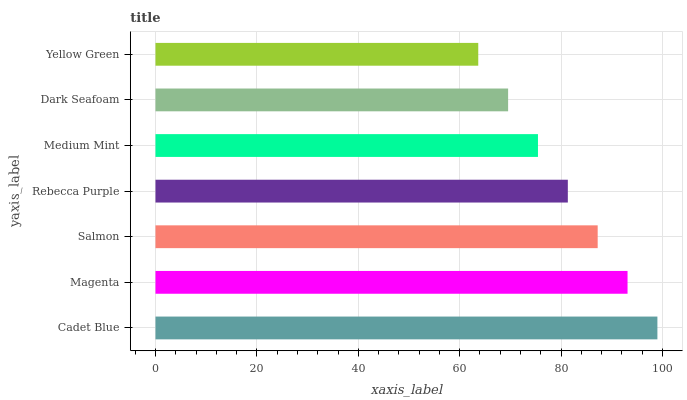Is Yellow Green the minimum?
Answer yes or no. Yes. Is Cadet Blue the maximum?
Answer yes or no. Yes. Is Magenta the minimum?
Answer yes or no. No. Is Magenta the maximum?
Answer yes or no. No. Is Cadet Blue greater than Magenta?
Answer yes or no. Yes. Is Magenta less than Cadet Blue?
Answer yes or no. Yes. Is Magenta greater than Cadet Blue?
Answer yes or no. No. Is Cadet Blue less than Magenta?
Answer yes or no. No. Is Rebecca Purple the high median?
Answer yes or no. Yes. Is Rebecca Purple the low median?
Answer yes or no. Yes. Is Salmon the high median?
Answer yes or no. No. Is Magenta the low median?
Answer yes or no. No. 